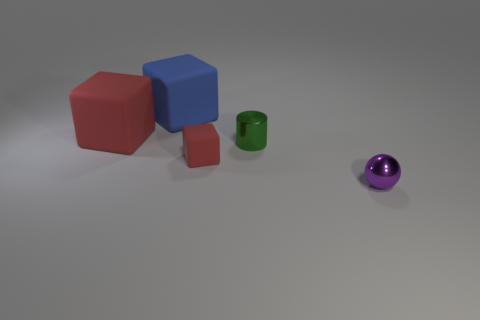Add 1 tiny cyan matte blocks. How many objects exist? 6 Subtract all red rubber blocks. How many blocks are left? 1 Subtract all blue cubes. How many cubes are left? 2 Subtract all yellow cylinders. How many red cubes are left? 2 Subtract all balls. How many objects are left? 4 Add 2 blue shiny objects. How many blue shiny objects exist? 2 Subtract 0 cyan spheres. How many objects are left? 5 Subtract 2 cubes. How many cubes are left? 1 Subtract all brown spheres. Subtract all green cubes. How many spheres are left? 1 Subtract all blocks. Subtract all small rubber blocks. How many objects are left? 1 